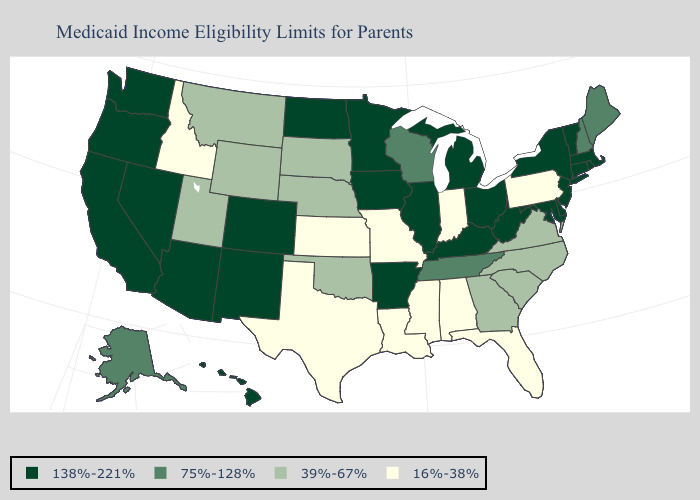What is the value of New Mexico?
Short answer required. 138%-221%. Name the states that have a value in the range 16%-38%?
Give a very brief answer. Alabama, Florida, Idaho, Indiana, Kansas, Louisiana, Mississippi, Missouri, Pennsylvania, Texas. What is the highest value in states that border Oklahoma?
Concise answer only. 138%-221%. Among the states that border Maryland , which have the highest value?
Answer briefly. Delaware, West Virginia. What is the highest value in the MidWest ?
Quick response, please. 138%-221%. Name the states that have a value in the range 75%-128%?
Be succinct. Alaska, Maine, New Hampshire, Tennessee, Wisconsin. Name the states that have a value in the range 138%-221%?
Keep it brief. Arizona, Arkansas, California, Colorado, Connecticut, Delaware, Hawaii, Illinois, Iowa, Kentucky, Maryland, Massachusetts, Michigan, Minnesota, Nevada, New Jersey, New Mexico, New York, North Dakota, Ohio, Oregon, Rhode Island, Vermont, Washington, West Virginia. Does Texas have the same value as Arizona?
Give a very brief answer. No. Among the states that border Kansas , which have the highest value?
Give a very brief answer. Colorado. What is the highest value in the USA?
Answer briefly. 138%-221%. Among the states that border New Jersey , which have the lowest value?
Write a very short answer. Pennsylvania. What is the value of Michigan?
Short answer required. 138%-221%. Does New Jersey have the lowest value in the USA?
Quick response, please. No. What is the value of South Carolina?
Write a very short answer. 39%-67%. What is the lowest value in the USA?
Concise answer only. 16%-38%. 